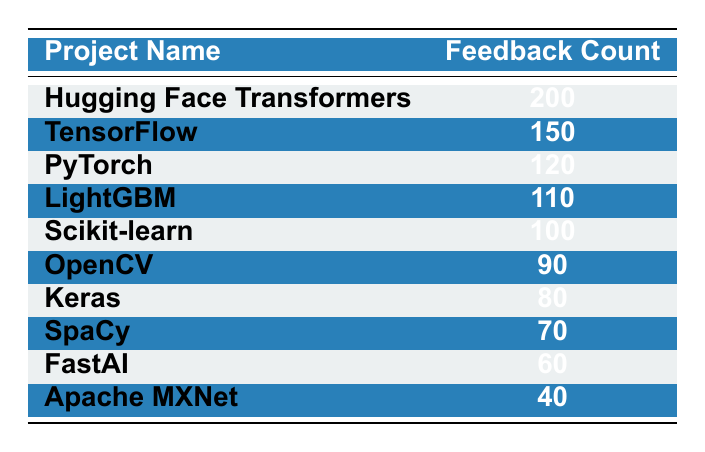What is the feedback count for Hugging Face Transformers? The table lists the feedback count for each project. For Hugging Face Transformers, the corresponding value in the feedback count column is 200.
Answer: 200 Which project received the least feedback? Looking at the feedback count column, the project with the lowest value is Apache MXNet, which has a feedback count of 40.
Answer: Apache MXNet What is the total feedback count for TensorFlow and PyTorch combined? To find the total feedback for these two projects, I add their individual feedback counts: TensorFlow (150) + PyTorch (120) = 270.
Answer: 270 Is the feedback count for Keras greater than the feedback count for SpaCy? From the table, Keras has a feedback count of 80 and SpaCy has a count of 70. Since 80 is greater than 70, the statement is true.
Answer: Yes What is the average feedback count for the projects listed? To find the average feedback count, first sum all feedback counts: 200 + 150 + 120 + 110 + 100 + 90 + 80 + 70 + 60 + 40 = 1020. There are 10 projects, so the average is 1020 divided by 10, which equals 102.
Answer: 102 How many projects have a feedback count greater than 100? By examining the table, the projects with feedback counts greater than 100 are Hugging Face Transformers (200), TensorFlow (150), PyTorch (120), and LightGBM (110). This gives a total of 4 projects.
Answer: 4 What is the difference in feedback count between the project with the highest and the lowest feedback? The project with the highest feedback is Hugging Face Transformers (200) and the lowest is Apache MXNet (40). The difference is calculated by subtracting 40 from 200, which equals 160.
Answer: 160 Which project received more feedback: FastAI or OpenCV? FastAI has a feedback count of 60, while OpenCV has a count of 90. Since 90 is greater than 60, OpenCV received more feedback than FastAI.
Answer: OpenCV How does the feedback for Scikit-learn compare to the average feedback count? Scikit-learn received a feedback count of 100. The average feedback count, as previously calculated, is 102. Since 100 is less than 102, Scikit-learn received less feedback than average.
Answer: Less than average 